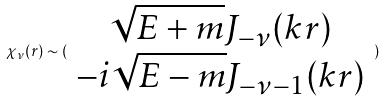Convert formula to latex. <formula><loc_0><loc_0><loc_500><loc_500>\chi _ { \nu } ( r ) \sim ( \begin{array} { c } \sqrt { E + m } J _ { - \nu } ( k r ) \\ - i \sqrt { E - m } J _ { - \nu - 1 } ( k r ) \end{array} )</formula> 